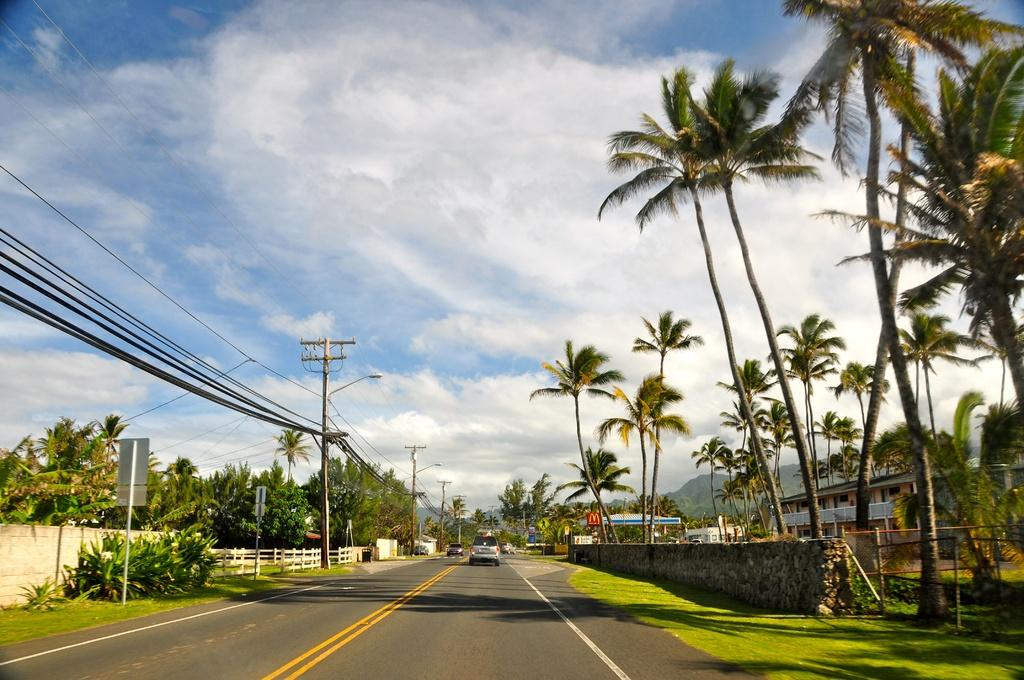What is the main feature in the center of the image? There is a road in the center of the image. What is happening on the road? Cars are present on the road. What can be seen in the background of the image? There are trees, at least one building, a fence, wires, and the sky visible in the background of the image. How much money is being exchanged between the cars on the road in the image? There is no indication of money being exchanged between the cars in the image. Can you see a wrench being used by any of the drivers in the image? There is no wrench visible in the image. 